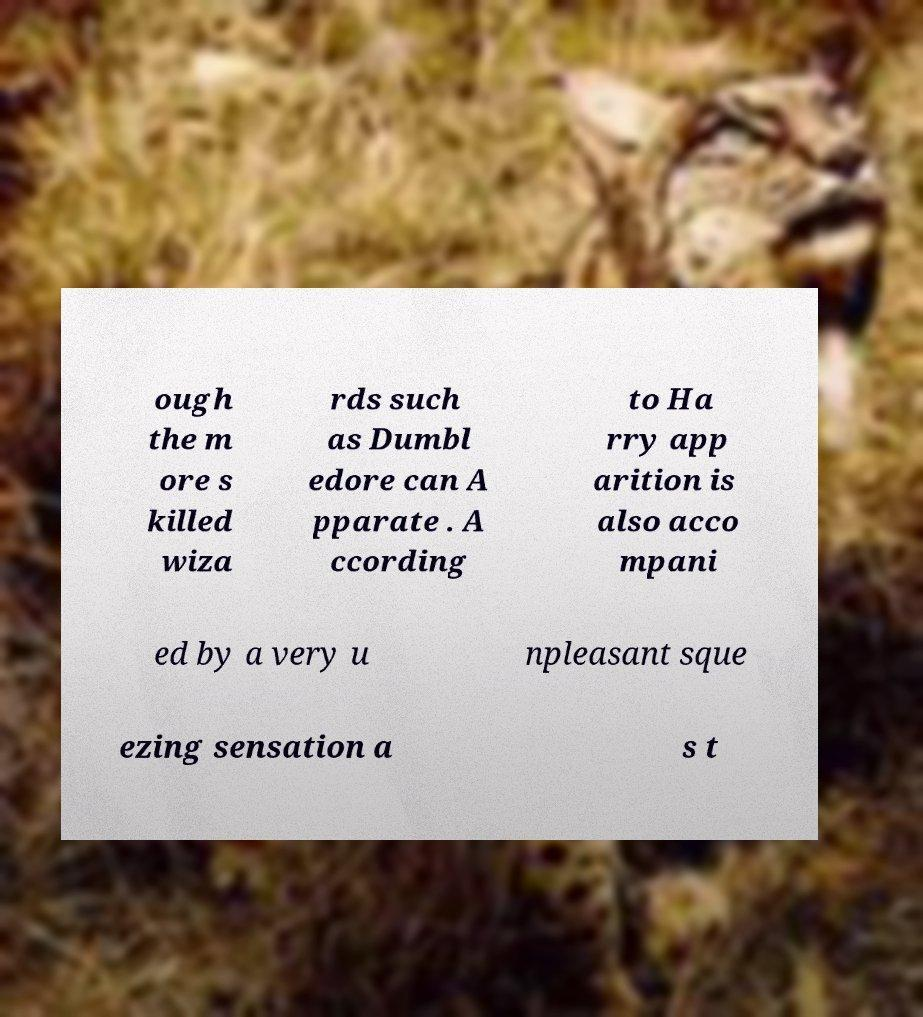Please read and relay the text visible in this image. What does it say? ough the m ore s killed wiza rds such as Dumbl edore can A pparate . A ccording to Ha rry app arition is also acco mpani ed by a very u npleasant sque ezing sensation a s t 